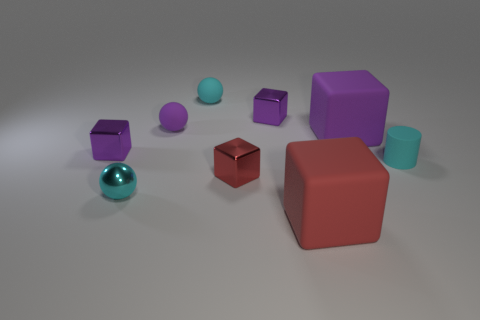Subtract all purple blocks. How many were subtracted if there are1purple blocks left? 2 Subtract all red metallic blocks. How many blocks are left? 4 Subtract all red blocks. How many blocks are left? 3 Subtract 2 cubes. How many cubes are left? 3 Add 5 tiny shiny balls. How many tiny shiny balls exist? 6 Subtract 0 blue cylinders. How many objects are left? 9 Subtract all cylinders. How many objects are left? 8 Subtract all red cylinders. Subtract all green cubes. How many cylinders are left? 1 Subtract all gray spheres. How many brown cubes are left? 0 Subtract all small cyan rubber balls. Subtract all small purple metal blocks. How many objects are left? 6 